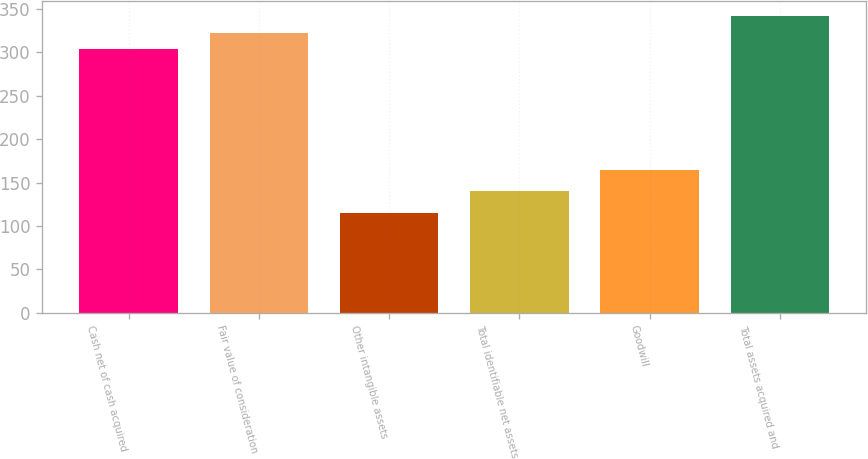Convert chart to OTSL. <chart><loc_0><loc_0><loc_500><loc_500><bar_chart><fcel>Cash net of cash acquired<fcel>Fair value of consideration<fcel>Other intangible assets<fcel>Total identifiable net assets<fcel>Goodwill<fcel>Total assets acquired and<nl><fcel>304<fcel>322.9<fcel>115<fcel>140<fcel>164<fcel>341.8<nl></chart> 